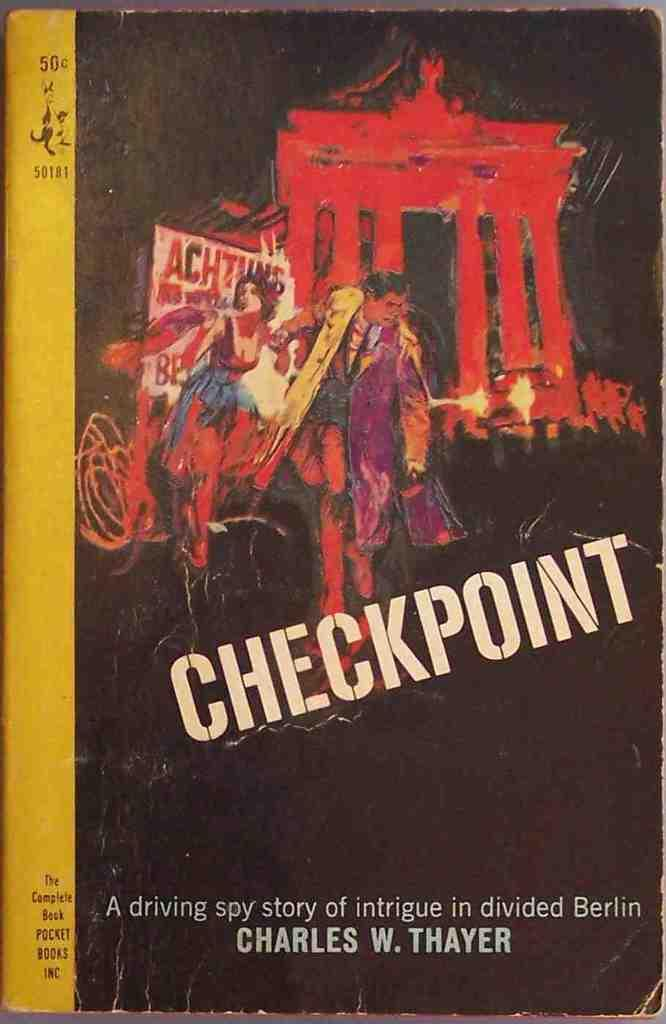<image>
Provide a brief description of the given image. A paperback book from years past promises a spy story full of intrigue. 